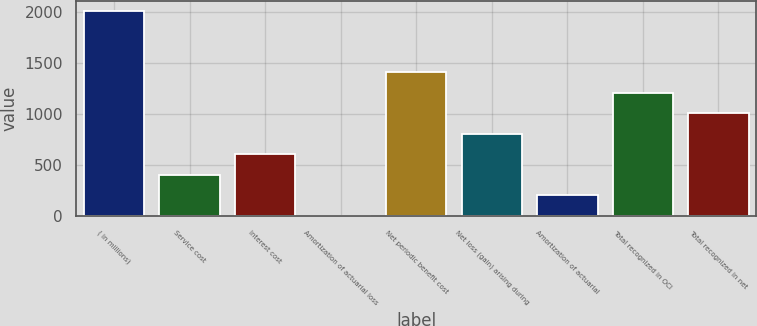<chart> <loc_0><loc_0><loc_500><loc_500><bar_chart><fcel>( in millions)<fcel>Service cost<fcel>Interest cost<fcel>Amortization of actuarial loss<fcel>Net periodic benefit cost<fcel>Net loss (gain) arising during<fcel>Amortization of actuarial<fcel>Total recognized in OCI<fcel>Total recognized in net<nl><fcel>2015<fcel>407.72<fcel>608.63<fcel>5.9<fcel>1412.27<fcel>809.54<fcel>206.81<fcel>1211.36<fcel>1010.45<nl></chart> 